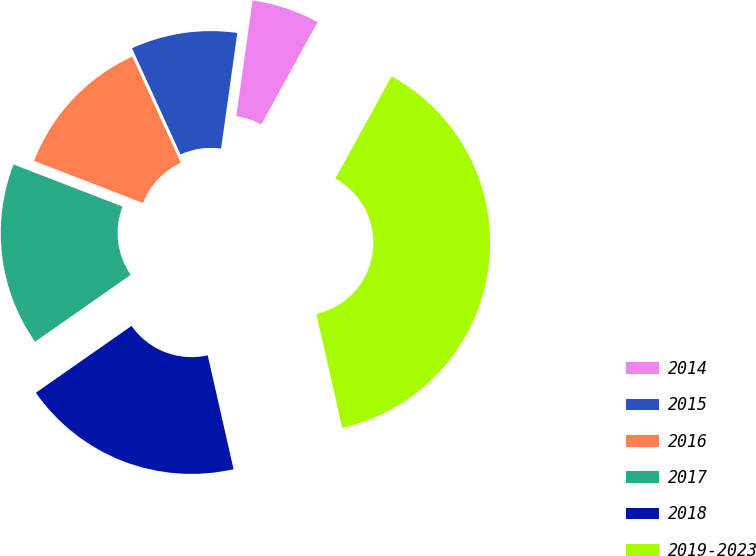<chart> <loc_0><loc_0><loc_500><loc_500><pie_chart><fcel>2014<fcel>2015<fcel>2016<fcel>2017<fcel>2018<fcel>2019-2023<nl><fcel>5.77%<fcel>9.04%<fcel>12.31%<fcel>15.58%<fcel>18.85%<fcel>38.46%<nl></chart> 